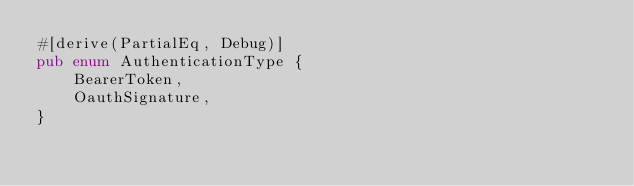Convert code to text. <code><loc_0><loc_0><loc_500><loc_500><_Rust_>#[derive(PartialEq, Debug)]
pub enum AuthenticationType {
    BearerToken,
    OauthSignature,
}
</code> 